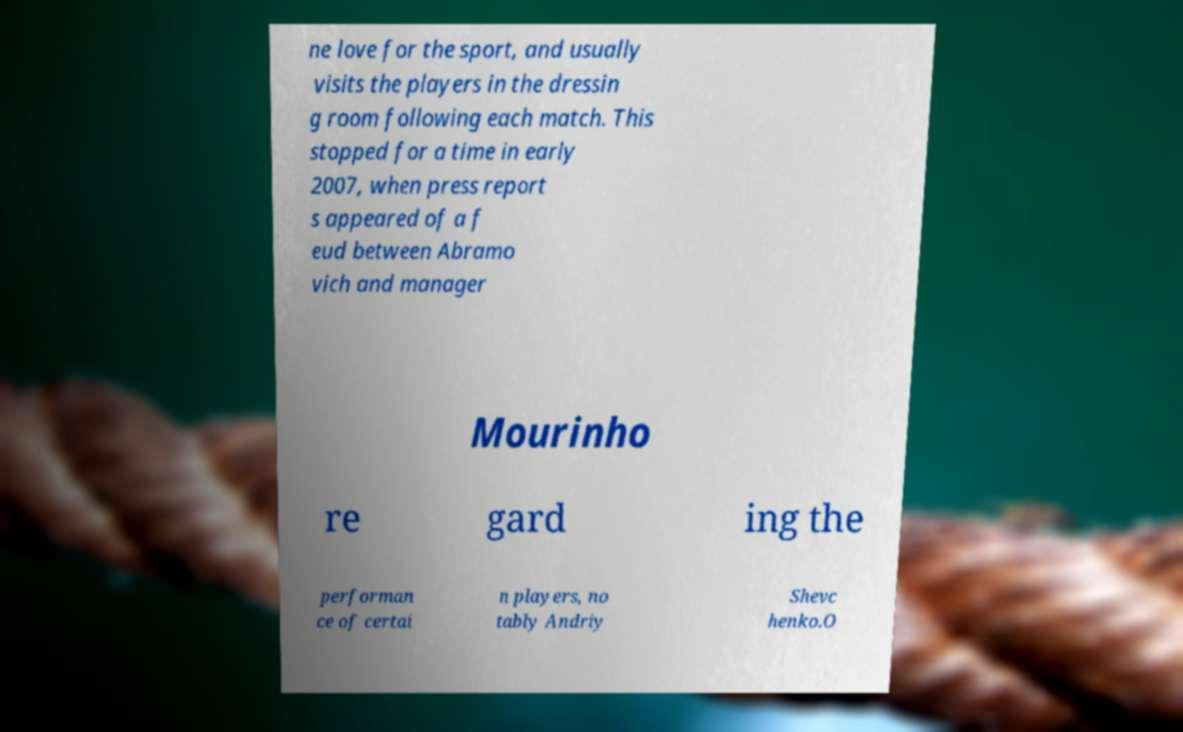There's text embedded in this image that I need extracted. Can you transcribe it verbatim? ne love for the sport, and usually visits the players in the dressin g room following each match. This stopped for a time in early 2007, when press report s appeared of a f eud between Abramo vich and manager Mourinho re gard ing the performan ce of certai n players, no tably Andriy Shevc henko.O 